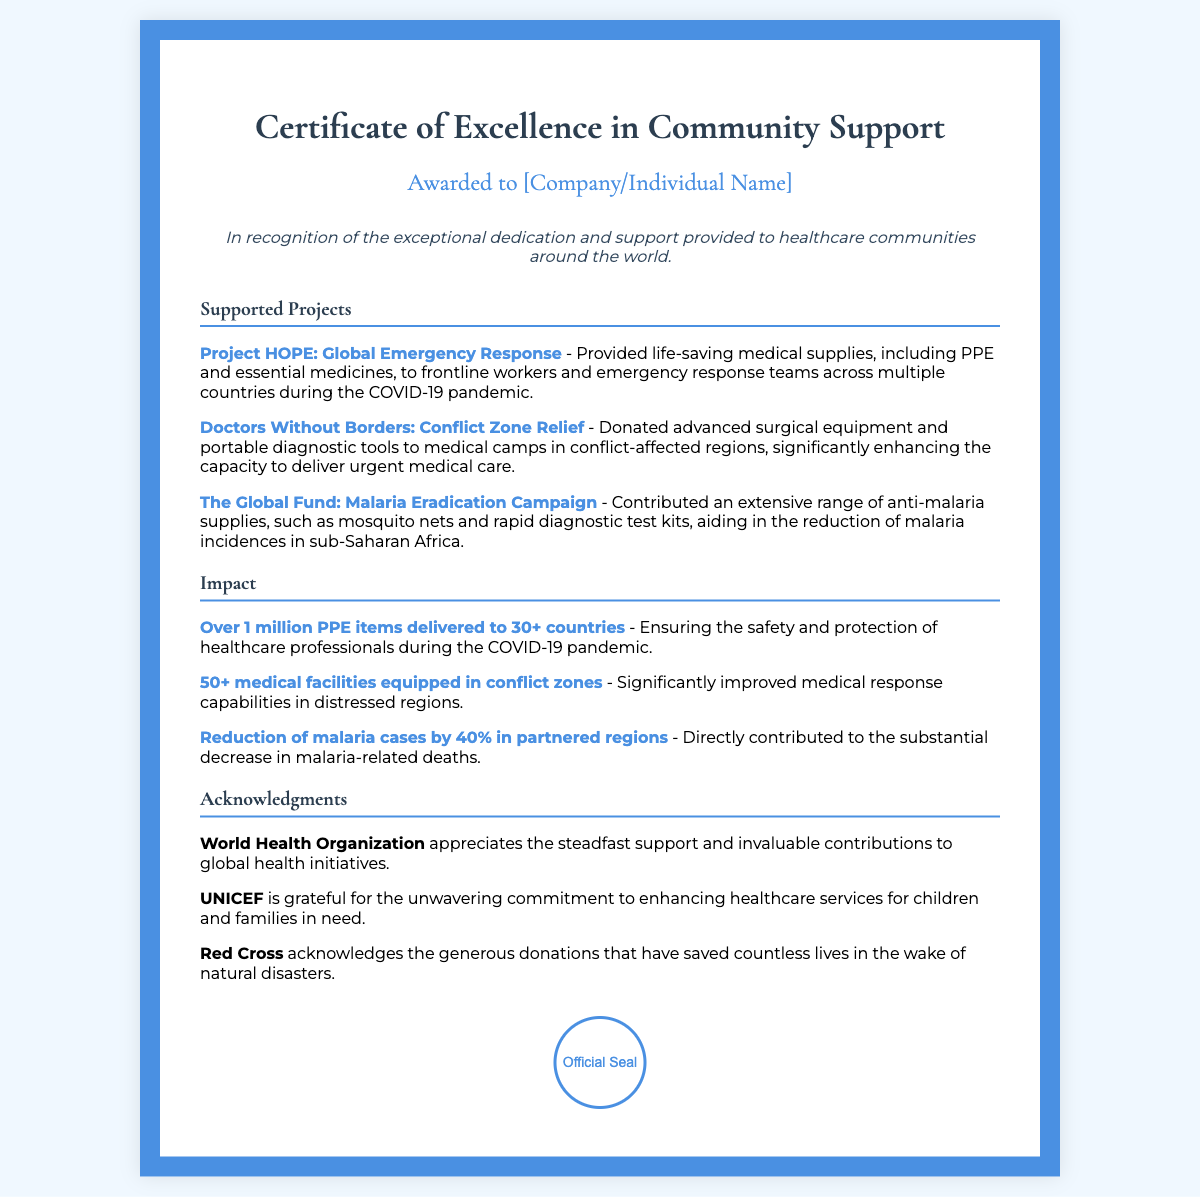what is the title of the certificate? The title of the certificate is specified at the top of the document, indicating its purpose.
Answer: Certificate of Excellence in Community Support who is the certificate awarded to? The document contains a section indicating the recipient of the award, which is a placeholder in the text.
Answer: [Company/Individual Name] how many countries received PPE items? The impact section states the number of countries that received PPE items during the COVID-19 pandemic.
Answer: 30+ what is the percentage reduction in malaria cases? The document states the impact of contributions towards malaria reduction.
Answer: 40% which organization acknowledges the contributions for natural disasters? The acknowledgments section lists various organizations, one of which has specific recognition for disaster-related contributions.
Answer: Red Cross what project provided medical supplies during the COVID-19 pandemic? The document lists several projects, one specifically addresses the COVID-19 pandemic.
Answer: Project HOPE: Global Emergency Response how many medical facilities were equipped in conflict zones? The impact section provides a numerical value regarding the number of facilities that received support.
Answer: 50+ which organization appreciates support for global health initiatives? The acknowledgments section mentions specific organizations that recognize contributions, including one known for global health work.
Answer: World Health Organization what is the color of the border on the certificate? The style of the certificate specifies a color used for its border.
Answer: #4a90e2 